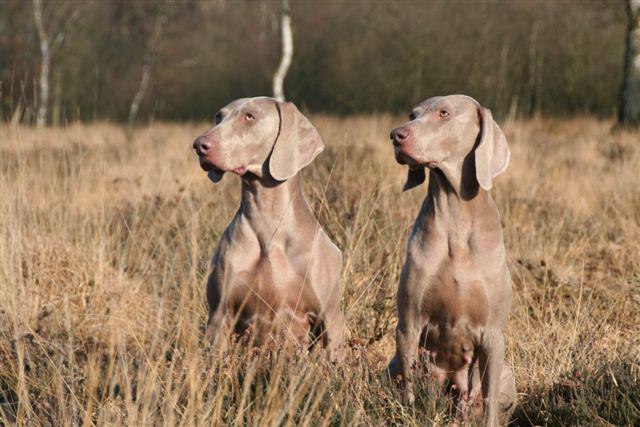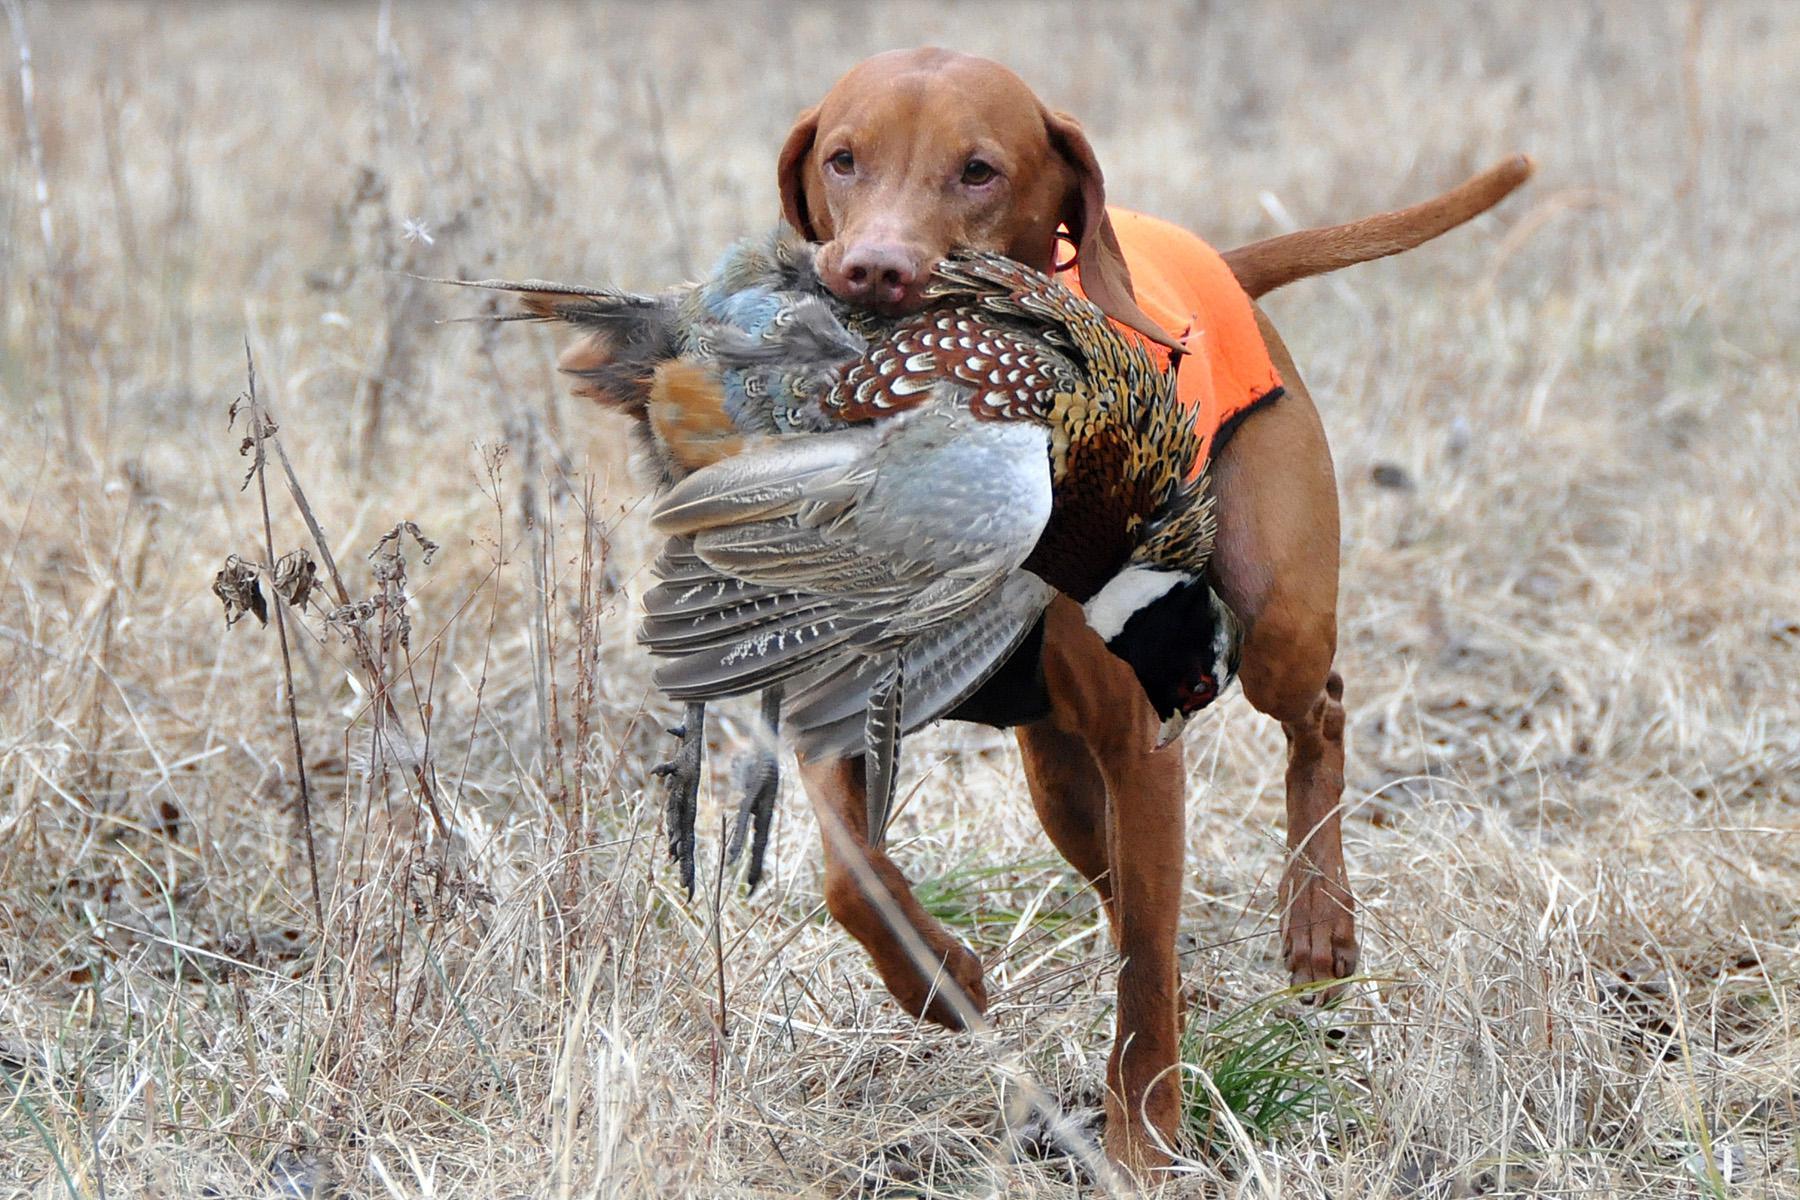The first image is the image on the left, the second image is the image on the right. Analyze the images presented: Is the assertion "The left image shows two look-alike dogs side-by-side, gazing in the same direction, and the right image shows one brown dog walking with an animal figure in its mouth." valid? Answer yes or no. Yes. The first image is the image on the left, the second image is the image on the right. For the images displayed, is the sentence "A dog walks through the grass as it carries something in its mouth." factually correct? Answer yes or no. Yes. 